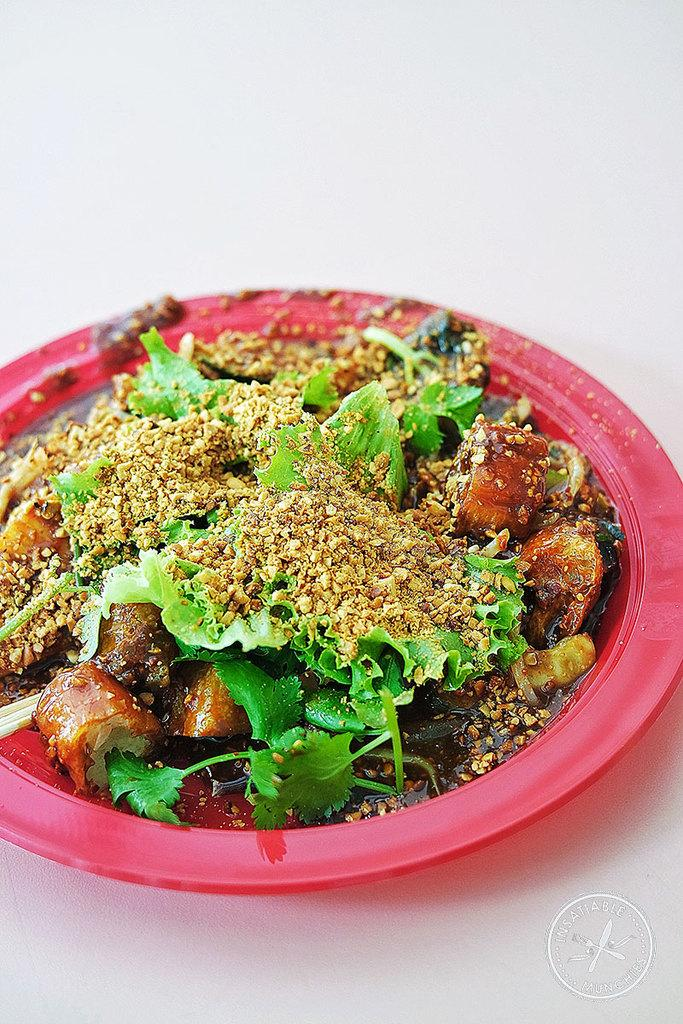What color is the plate in the image? The plate in the image is pink colored. What is on the plate? The plate contains curry. How is the curry decorated? The curry has leaf garnish. What is sprinkled on top of the curry? There is some powder on the curry. What type of creature can be seen playing with a board in the image? There is no creature or board present in the image; it features a pink colored plate with curry. How many dogs are visible in the image? There are no dogs present in the image. 